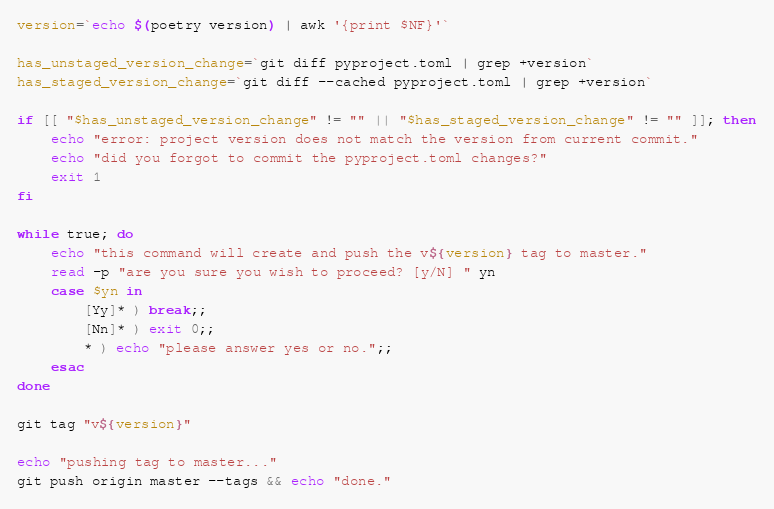<code> <loc_0><loc_0><loc_500><loc_500><_Bash_>version=`echo $(poetry version) | awk '{print $NF}'`

has_unstaged_version_change=`git diff pyproject.toml | grep +version`
has_staged_version_change=`git diff --cached pyproject.toml | grep +version`

if [[ "$has_unstaged_version_change" != "" || "$has_staged_version_change" != "" ]]; then
    echo "error: project version does not match the version from current commit."
    echo "did you forgot to commit the pyproject.toml changes?"
    exit 1
fi

while true; do
    echo "this command will create and push the v${version} tag to master."
    read -p "are you sure you wish to proceed? [y/N] " yn
    case $yn in
        [Yy]* ) break;;
        [Nn]* ) exit 0;;
        * ) echo "please answer yes or no.";;
    esac
done

git tag "v${version}"

echo "pushing tag to master..."
git push origin master --tags && echo "done."
</code> 